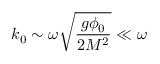Convert formula to latex. <formula><loc_0><loc_0><loc_500><loc_500>k _ { 0 } \sim \omega \sqrt { \frac { g \phi _ { 0 } } { 2 M ^ { 2 } } } \ll \omega</formula> 